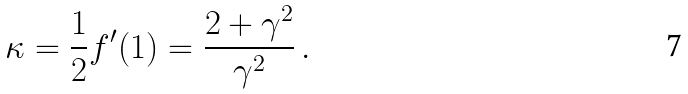Convert formula to latex. <formula><loc_0><loc_0><loc_500><loc_500>\kappa = \frac { 1 } { 2 } f ^ { \prime } ( 1 ) = \frac { 2 + \gamma ^ { 2 } } { \gamma ^ { 2 } } \, .</formula> 